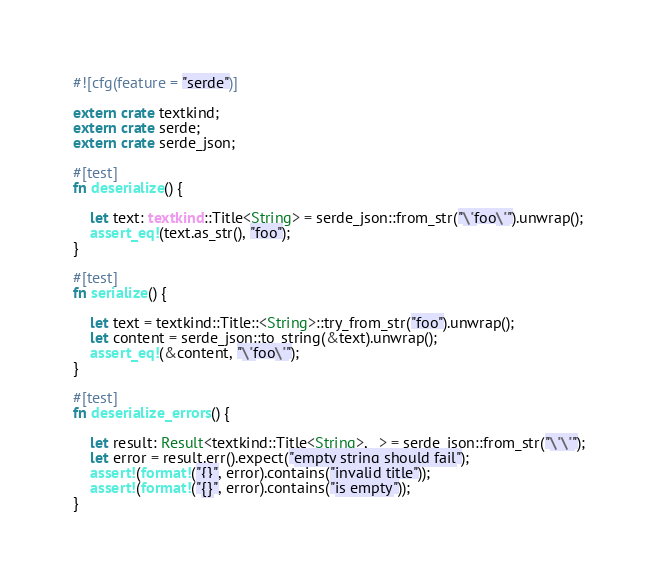<code> <loc_0><loc_0><loc_500><loc_500><_Rust_>#![cfg(feature = "serde")]

extern crate textkind;
extern crate serde;
extern crate serde_json;

#[test]
fn deserialize() {

    let text: textkind::Title<String> = serde_json::from_str("\"foo\"").unwrap();
    assert_eq!(text.as_str(), "foo");
}

#[test]
fn serialize() {

    let text = textkind::Title::<String>::try_from_str("foo").unwrap();
    let content = serde_json::to_string(&text).unwrap();
    assert_eq!(&content, "\"foo\"");
}

#[test]
fn deserialize_errors() {

    let result: Result<textkind::Title<String>, _> = serde_json::from_str("\"\"");
    let error = result.err().expect("empty string should fail");
    assert!(format!("{}", error).contains("invalid title"));
    assert!(format!("{}", error).contains("is empty"));
}
</code> 